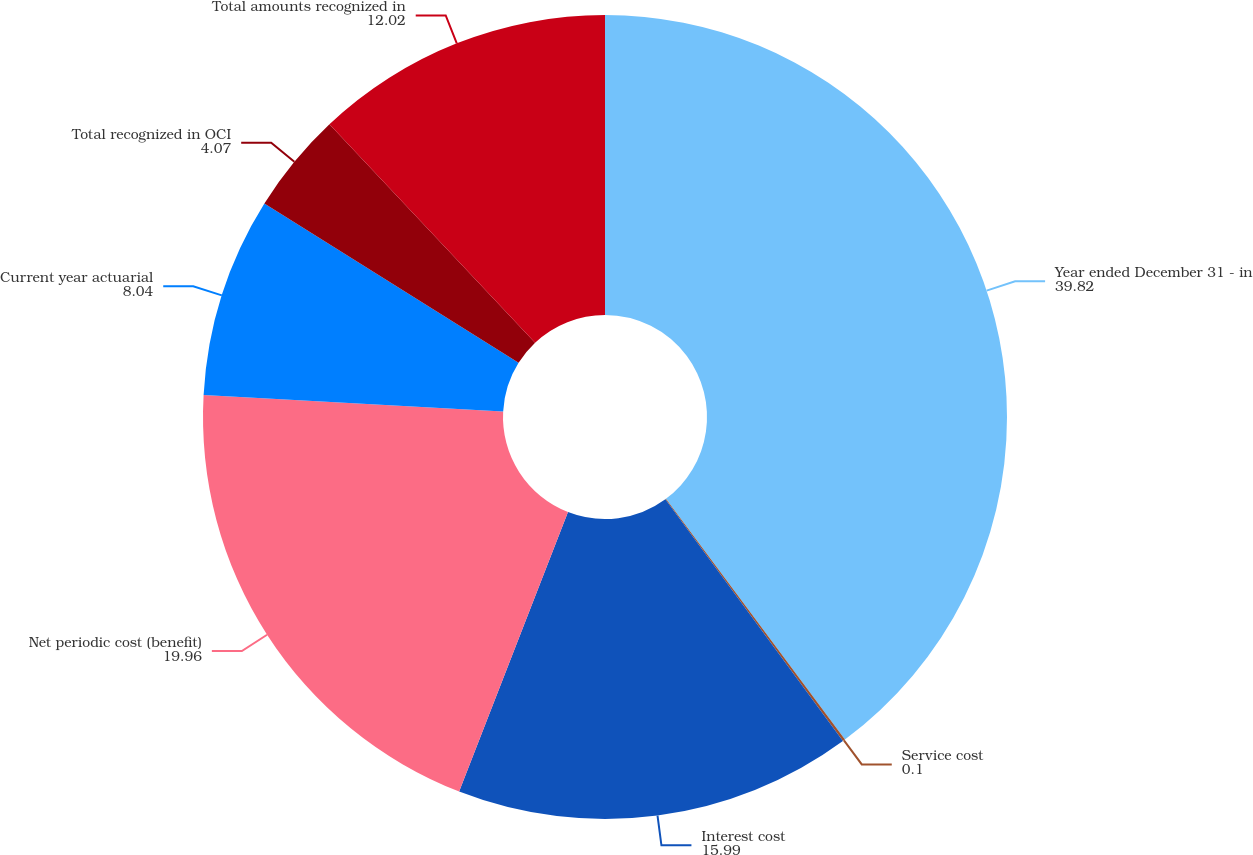<chart> <loc_0><loc_0><loc_500><loc_500><pie_chart><fcel>Year ended December 31 - in<fcel>Service cost<fcel>Interest cost<fcel>Net periodic cost (benefit)<fcel>Current year actuarial<fcel>Total recognized in OCI<fcel>Total amounts recognized in<nl><fcel>39.82%<fcel>0.1%<fcel>15.99%<fcel>19.96%<fcel>8.04%<fcel>4.07%<fcel>12.02%<nl></chart> 